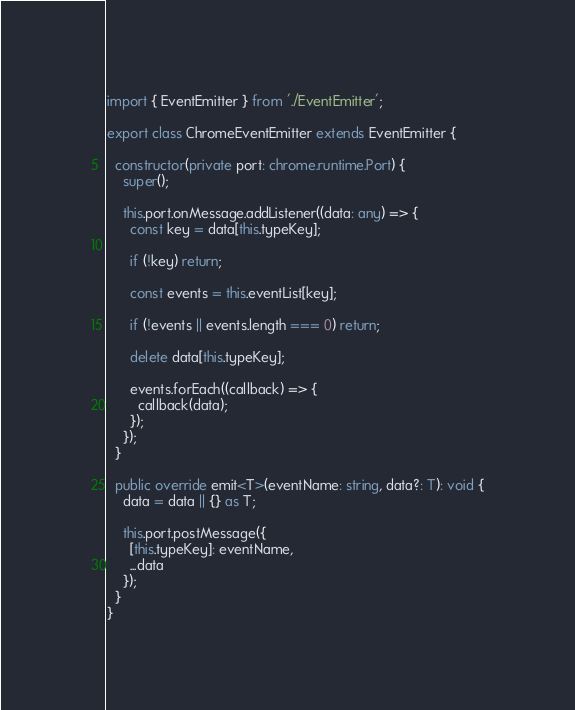Convert code to text. <code><loc_0><loc_0><loc_500><loc_500><_TypeScript_>import { EventEmitter } from './EventEmitter';

export class ChromeEventEmitter extends EventEmitter {

  constructor(private port: chrome.runtime.Port) {
    super();

    this.port.onMessage.addListener((data: any) => {
      const key = data[this.typeKey];

      if (!key) return;

      const events = this.eventList[key];

      if (!events || events.length === 0) return;

      delete data[this.typeKey];

      events.forEach((callback) => {
        callback(data);
      });
    });
  }

  public override emit<T>(eventName: string, data?: T): void {
    data = data || {} as T;

    this.port.postMessage({
      [this.typeKey]: eventName,
      ...data
    });
  }
}
</code> 